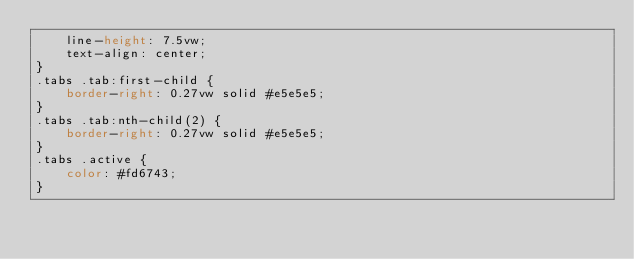Convert code to text. <code><loc_0><loc_0><loc_500><loc_500><_CSS_>    line-height: 7.5vw;
    text-align: center;
}
.tabs .tab:first-child {
    border-right: 0.27vw solid #e5e5e5;
}
.tabs .tab:nth-child(2) {
    border-right: 0.27vw solid #e5e5e5;
}
.tabs .active {
    color: #fd6743;
}

</code> 